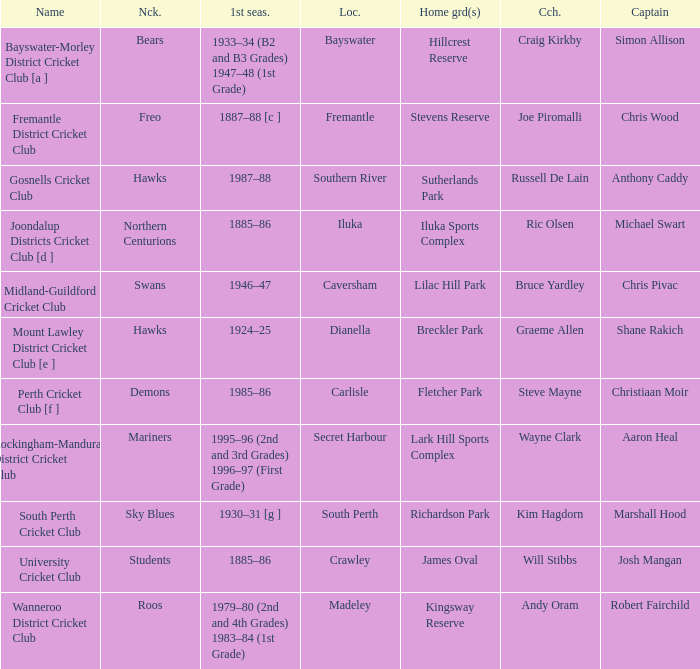What is the location for the club with the nickname the bears? Bayswater. 